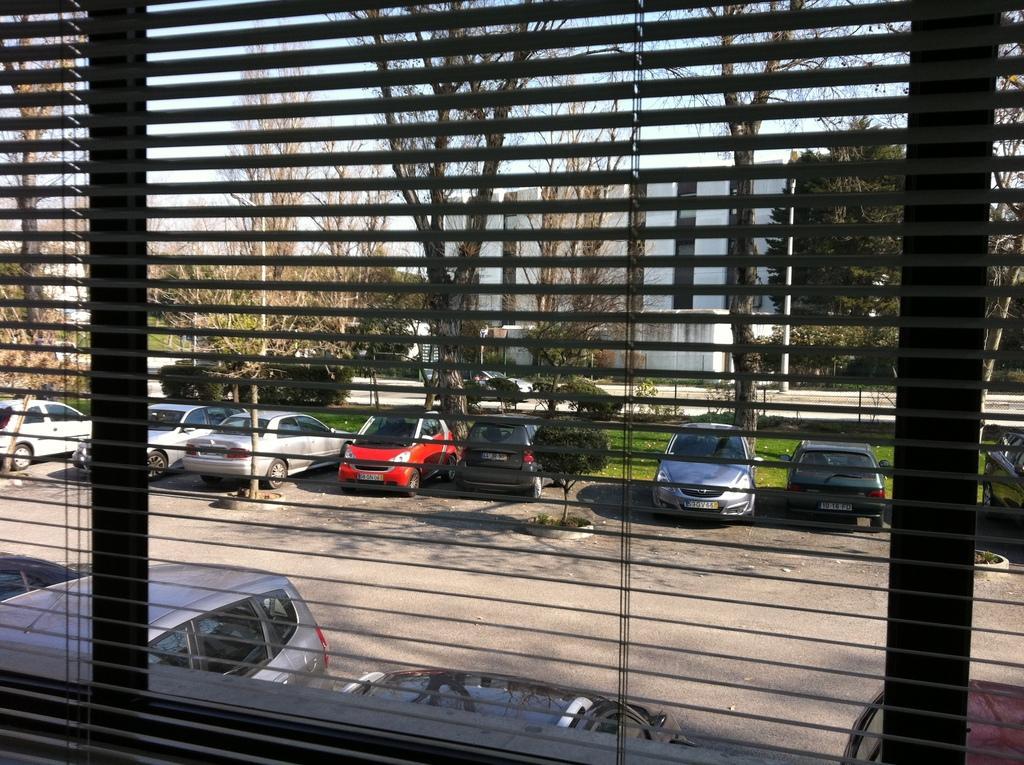Could you give a brief overview of what you see in this image? This picture is taken inside the window. Outside of the window, we can see some vehicles which are placed on the road, trees, building, glass window, pole. At the top, we can see a sky, at the bottom, we can see a road and a grass. 